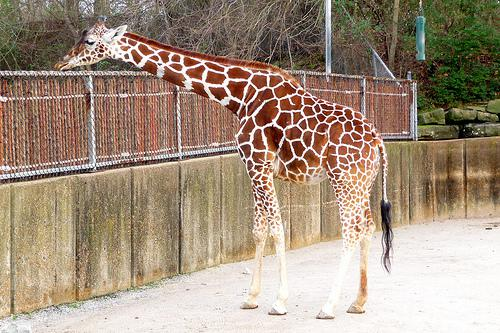Question: how many giraffes are in the picture?
Choices:
A. 2.
B. 3.
C. 6.
D. 1.
Answer with the letter. Answer: D Question: what animal is featured?
Choices:
A. Tiger.
B. Giraffe.
C. Bear.
D. Hippo.
Answer with the letter. Answer: B Question: where is the giraffe's head?
Choices:
A. In the leaves.
B. Over the gate.
C. High up.
D. Over the fence.
Answer with the letter. Answer: D Question: what color are the giraffe's spots?
Choices:
A. Green.
B. Red.
C. Blue.
D. Brown.
Answer with the letter. Answer: D 